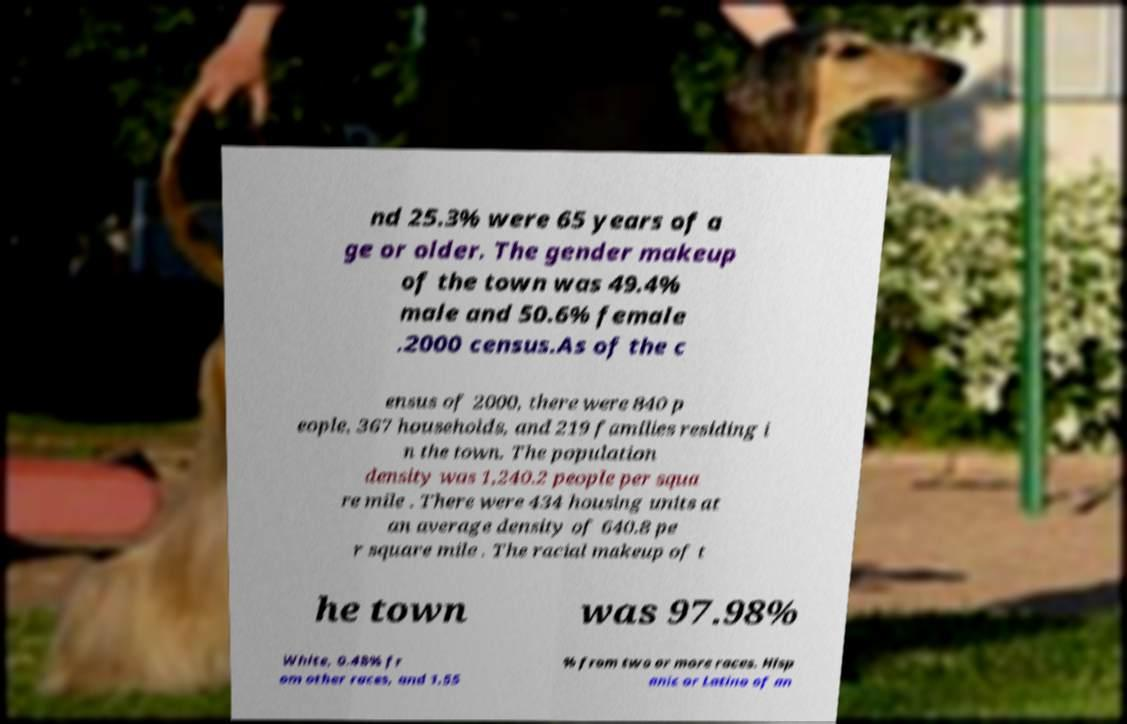Please read and relay the text visible in this image. What does it say? nd 25.3% were 65 years of a ge or older. The gender makeup of the town was 49.4% male and 50.6% female .2000 census.As of the c ensus of 2000, there were 840 p eople, 367 households, and 219 families residing i n the town. The population density was 1,240.2 people per squa re mile . There were 434 housing units at an average density of 640.8 pe r square mile . The racial makeup of t he town was 97.98% White, 0.48% fr om other races, and 1.55 % from two or more races. Hisp anic or Latino of an 